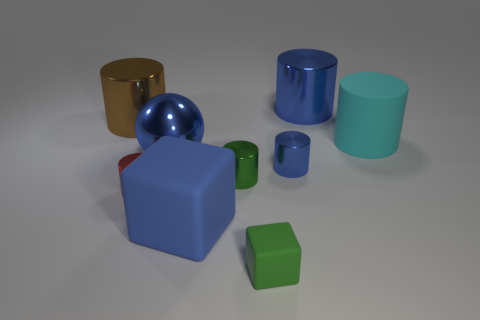What is the size of the block that is the same color as the big shiny ball?
Make the answer very short. Large. There is a large shiny object that is in front of the big cyan matte cylinder; is it the same color as the big matte block?
Ensure brevity in your answer.  Yes. Is there any other thing that is the same color as the small matte block?
Keep it short and to the point. Yes. What is the shape of the big blue metal thing behind the large blue shiny object that is in front of the cyan thing?
Keep it short and to the point. Cylinder. Are there more large blue metallic objects than brown metal cylinders?
Offer a terse response. Yes. How many objects are on the right side of the brown metallic object and behind the tiny blue thing?
Make the answer very short. 3. How many things are on the left side of the tiny green matte thing in front of the big metal ball?
Make the answer very short. 5. How many things are either large shiny objects that are behind the large cyan cylinder or shiny things that are in front of the metallic ball?
Offer a very short reply. 5. What is the material of the green thing that is the same shape as the brown thing?
Your response must be concise. Metal. How many things are either matte objects in front of the big cyan matte cylinder or shiny balls?
Give a very brief answer. 3. 